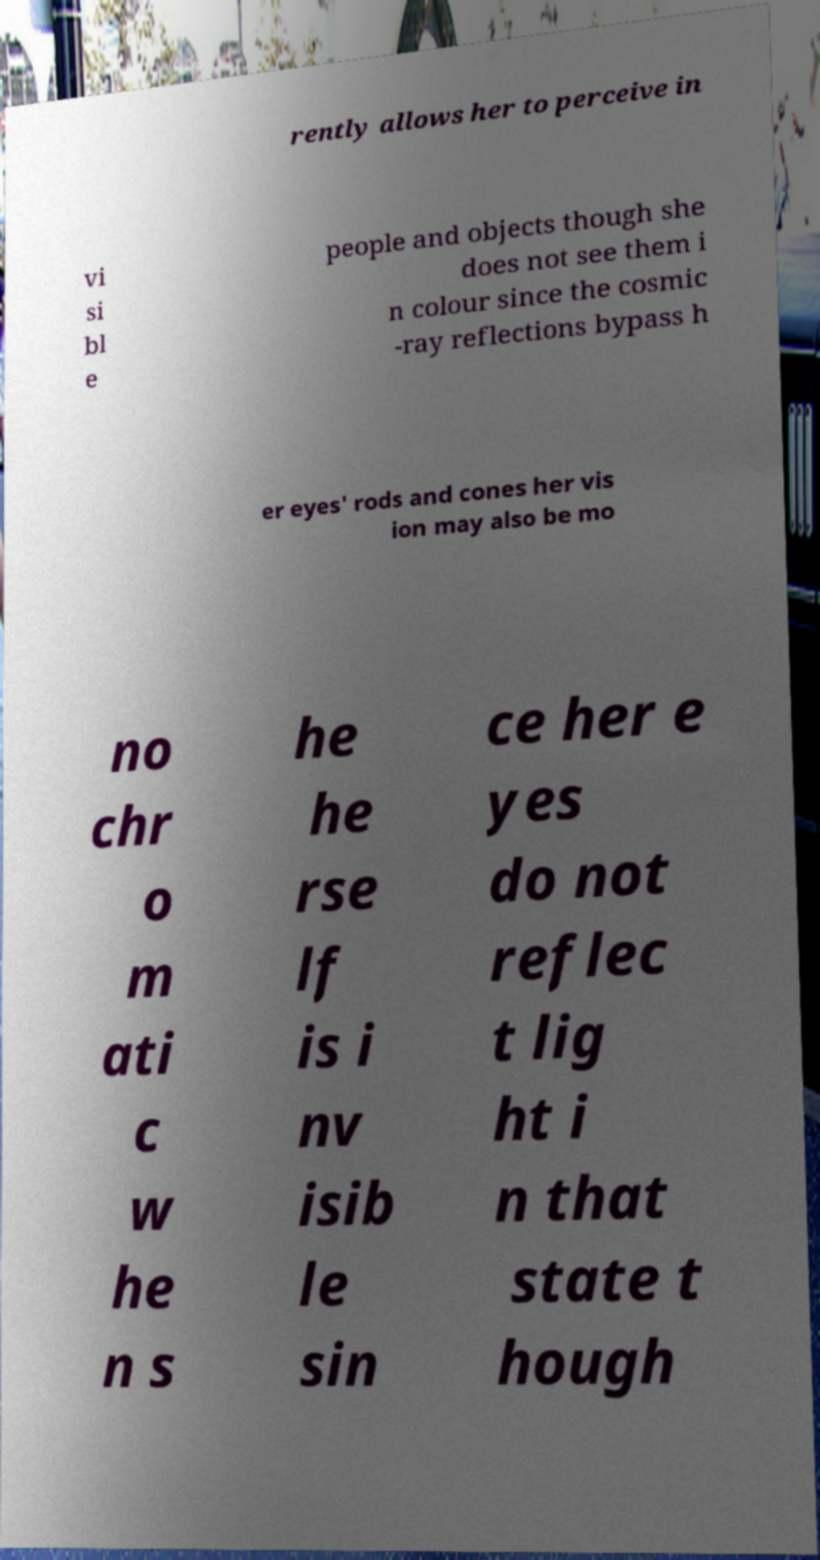Could you assist in decoding the text presented in this image and type it out clearly? rently allows her to perceive in vi si bl e people and objects though she does not see them i n colour since the cosmic -ray reflections bypass h er eyes' rods and cones her vis ion may also be mo no chr o m ati c w he n s he he rse lf is i nv isib le sin ce her e yes do not reflec t lig ht i n that state t hough 